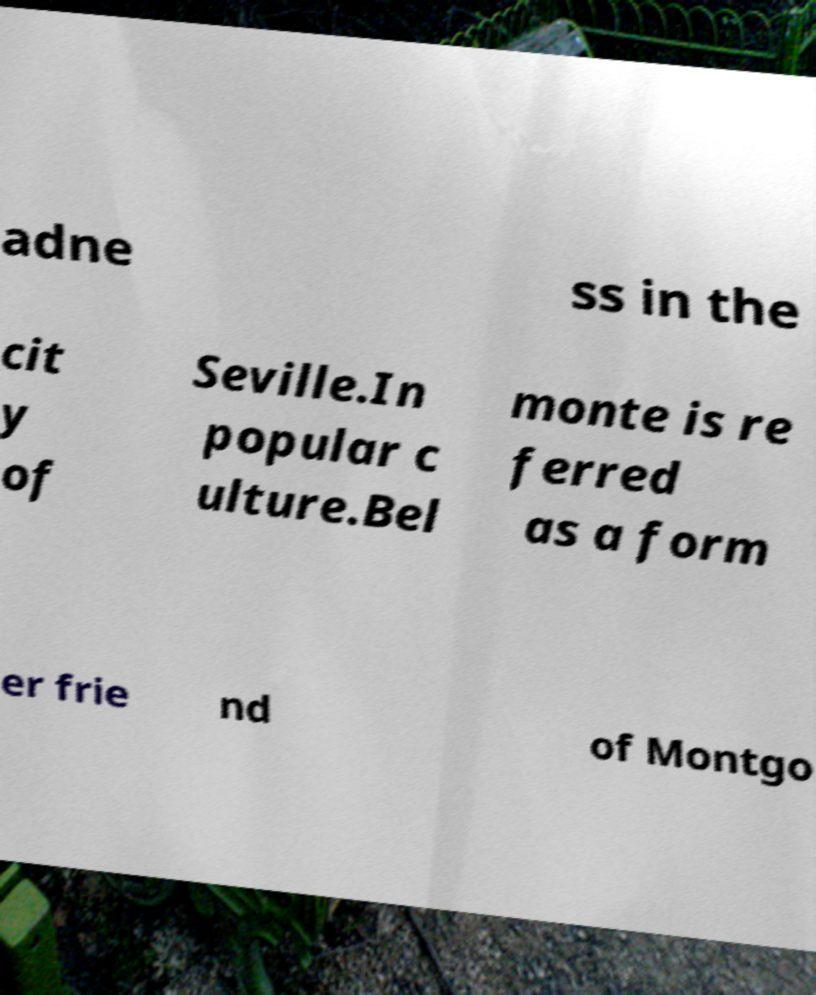Can you read and provide the text displayed in the image?This photo seems to have some interesting text. Can you extract and type it out for me? adne ss in the cit y of Seville.In popular c ulture.Bel monte is re ferred as a form er frie nd of Montgo 